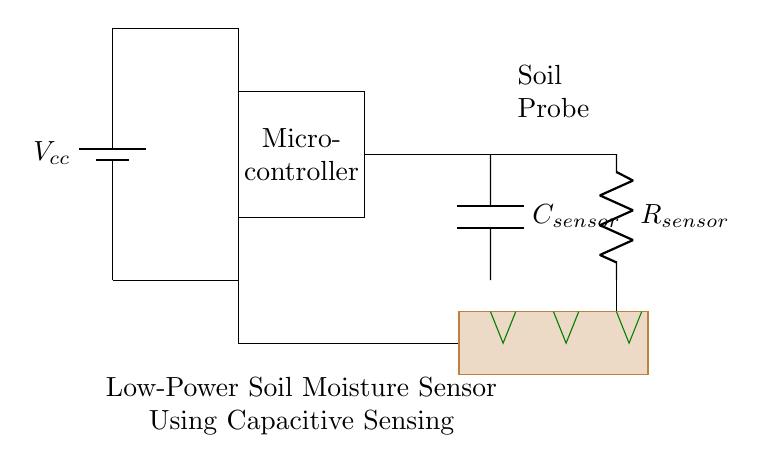What is the main power source for this circuit? The circuit uses a battery as the power source, indicated by the battery symbol.
Answer: Battery What type of sensor is used in this circuit? The circuit features a capacitive sensor, as labeled by the capacitor symbol next to it.
Answer: Capacitive sensor What is the value of the resistor connected to the sensor? The resistor connected to the sensor is labeled as R sensor; however, no specific value is given in the circuit.
Answer: R sensor What does the brown rectangle represent in this diagram? The brown rectangle represents the soil in which the sensor probes are placed, indicating the sensor's environment.
Answer: Soil How does the signal flow from the microcontroller to the sensor? The signal flows from the microcontroller to the sensor through a direct connection, which is shown by the line completing the circuit between these components.
Answer: Direct connection Why is a low-power circuit important for a soil moisture sensor? A low-power circuit is crucial as it can operate over extended periods without draining the battery quickly, which is essential for continuous soil monitoring in agricultural applications.
Answer: Extended battery life 